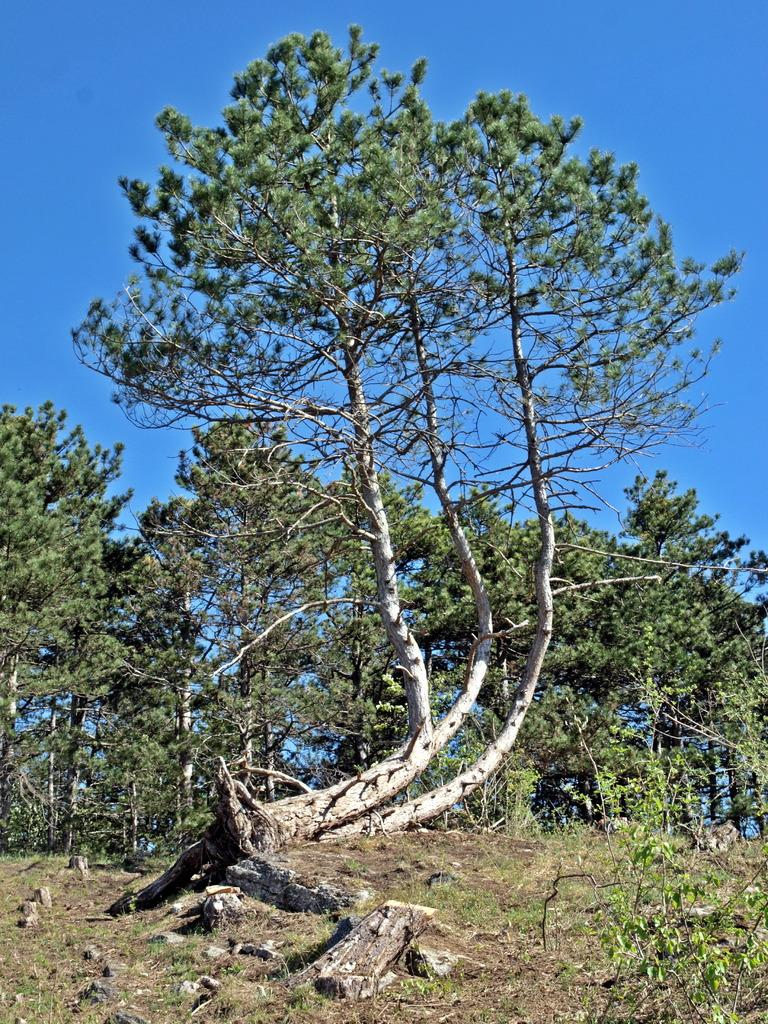What type of plant can be seen in the image? There is a tree in the image. What colors are present on the tree? The tree is green and cream in color. Where is the tree located in relation to the ground? The tree is on the ground. What else can be seen in the background of the image? There are trees visible in the background of the image. What color is the sky in the image? The sky is blue in color. Can you see any donkeys or insects interacting with the tree in the image? There are no donkeys or insects present in the image, and therefore no such interaction can be observed. What type of lace is draped over the tree in the image? There is no lace present in the image; the tree is simply green and cream in color. 